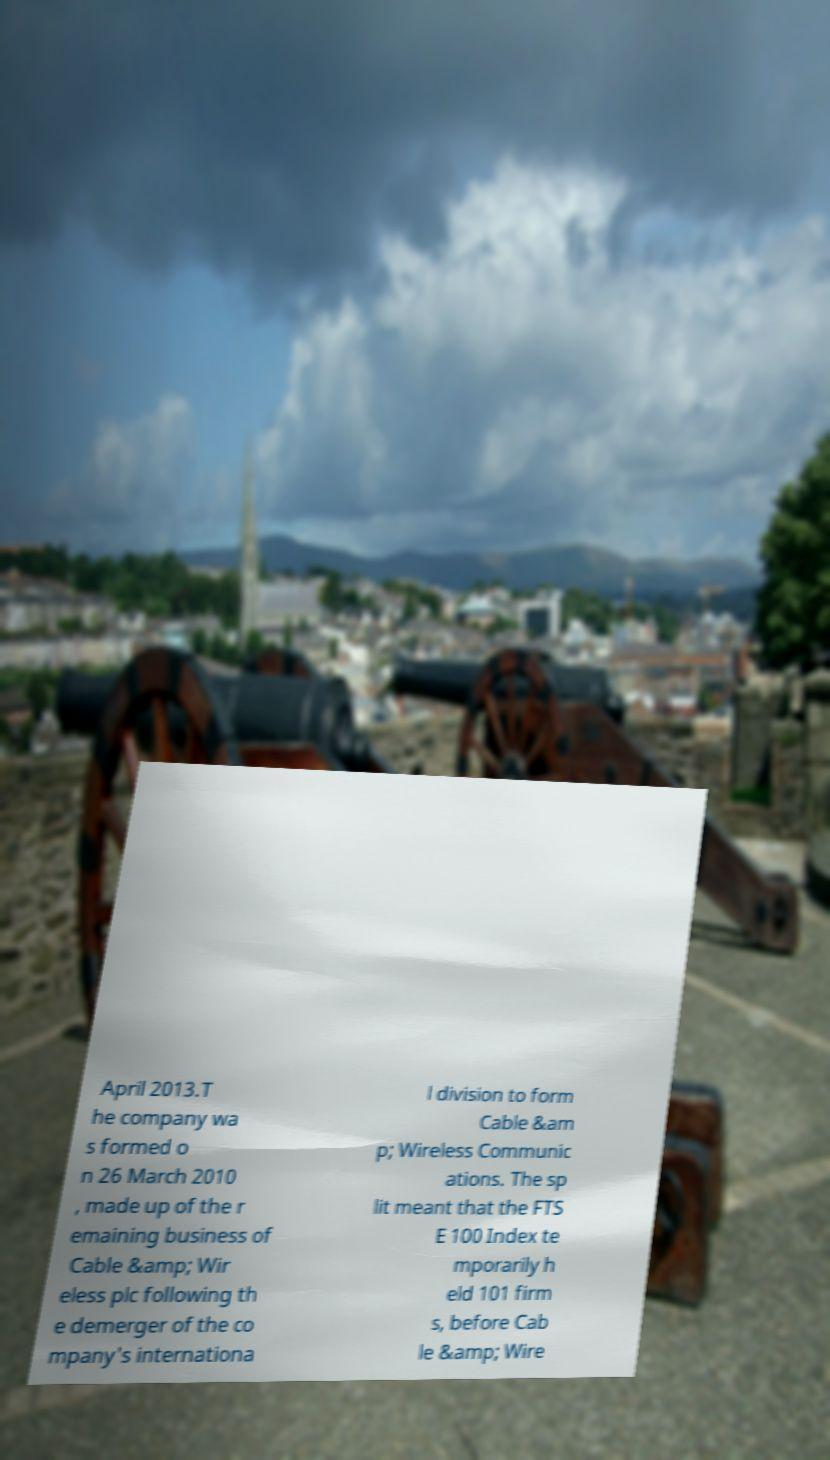Please read and relay the text visible in this image. What does it say? April 2013.T he company wa s formed o n 26 March 2010 , made up of the r emaining business of Cable &amp; Wir eless plc following th e demerger of the co mpany's internationa l division to form Cable &am p; Wireless Communic ations. The sp lit meant that the FTS E 100 Index te mporarily h eld 101 firm s, before Cab le &amp; Wire 